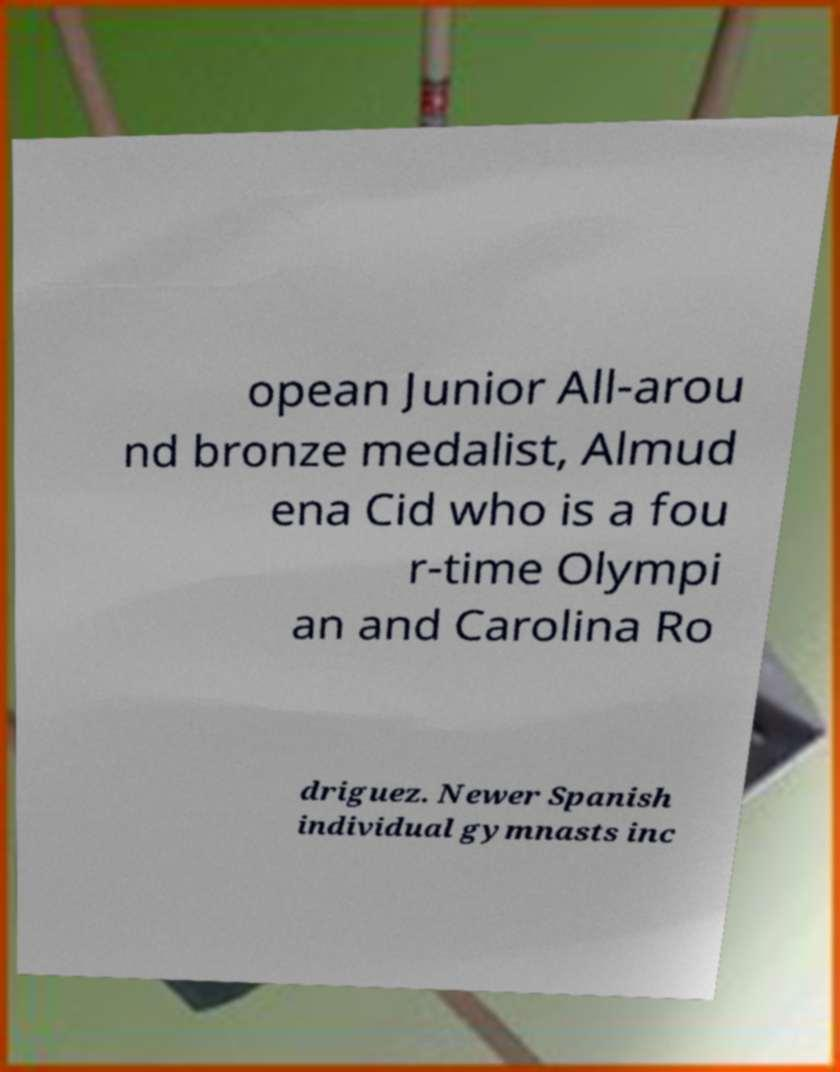Can you accurately transcribe the text from the provided image for me? opean Junior All-arou nd bronze medalist, Almud ena Cid who is a fou r-time Olympi an and Carolina Ro driguez. Newer Spanish individual gymnasts inc 